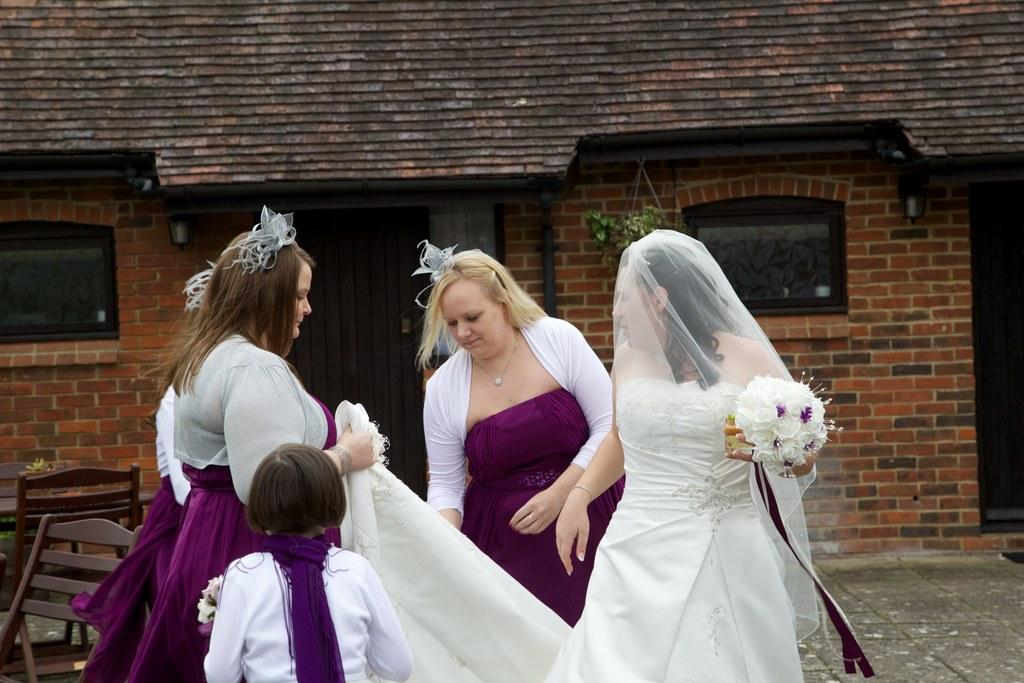How many women are in the image? There are many women in the image. Can you describe the attire of the woman on the right? The woman on the right is wearing a white gown. What is the woman on the right holding? The woman on the right is holding a white flower bouquet. What can be seen in the background of the image? There is a building with a brick wall in the background of the image. What type of business is being conducted by the woman on the left with the donkey? There is no woman on the left and no donkey present in the image. 